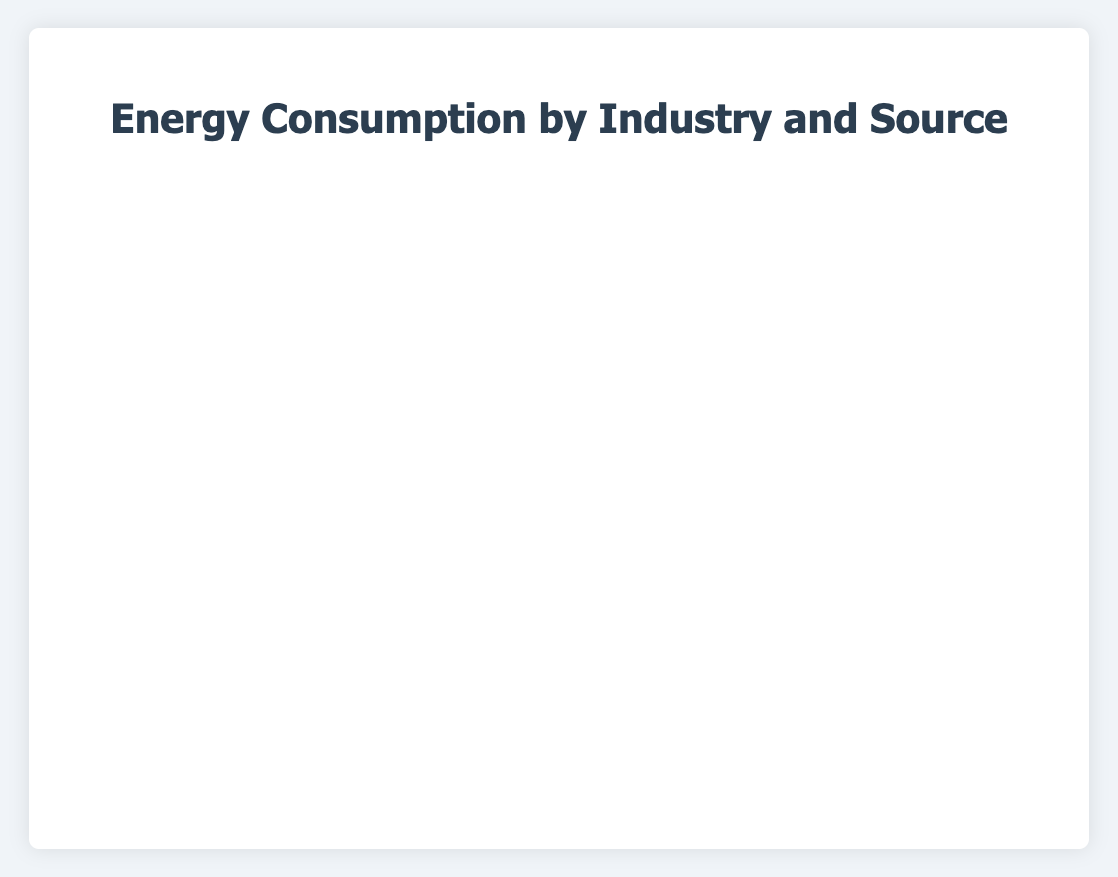What industry consumes the highest percentage of natural gas? By visually comparing the horizontal bars for natural gas (color-coded in orange) across all industries, we can see that the Mining industry has the longest horizontal bar for natural gas. Hence, Mining consumes the highest percentage of natural gas at 40%.
Answer: Mining Which industry has the lowest consumption of oil? By visually comparing the horizontal bars for oil (color-coded in red), we observe that both Manufacturing and Mining have the shortest bars, each representing 5% consumption of oil.
Answer: Manufacturing and Mining What is the combined percentage of electricity and natural gas consumption in the Residential industry? In the Residential industry, the percentages of electricity and natural gas are 50% and 20%, respectively. Adding these two values: 50% + 20% = 70%.
Answer: 70% Is the percentage of renewable energy consumption in the Transportation industry higher than in the Manufacturing industry? By comparing the horizontal bars for renewable energy (color-coded in green) in both industries, we notice that the Transportation industry has a shorter bar of 5%, while the Manufacturing industry has a bar of 10%. Therefore, the percentage in the Manufacturing industry is higher.
Answer: No Which industry utilizes coal more excessively, Manufacturing or Commercial? By comparing the horizontal bars for coal (color-coded in dark grey) between the Manufacturing and Commercial industries, we notice that Manufacturing has a longer bar representing 20%, whereas Commercial has a shorter bar representing 5%. Therefore, Manufacturing uses more coal.
Answer: Manufacturing How does oil consumption in the Residential sector compare to the Commercial sector? By visually comparing the horizontal bars for oil (red) in both sectors, we observe that both the Residential and Commercial sectors have equal-length bars, each representing 10% consumption of oil.
Answer: Equal What is the total energy consumption of renewable sources in all industries combined? Summing up the percentages of renewable energy consumption across all industries, we have: Manufacturing (10%) + Transportation (5%) + Residential (15%) + Commercial (15%) + Agriculture (20%) + Mining (10%) = 75%.
Answer: 75% Is the percentage of electricity consumption in the Agriculture industry greater than in the Mining industry? By comparing the horizontal bars for electricity (blue) in both industries, we find that the Agriculture industry has a bar representing 40%, while the Mining industry has a bar representing 25%. Therefore, the percentage is greater in Agriculture.
Answer: Yes Which industry relies most on oil for its energy consumption? By visually comparing the horizontal bars for oil (red) across all industries, we observe that the Transportation industry has the longest bar at 60%, indicating its highest reliance on oil.
Answer: Transportation 